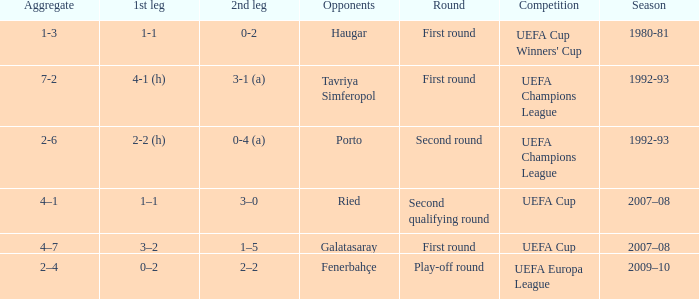What is the total number of 2nd leg where aggregate is 7-2 1.0. 